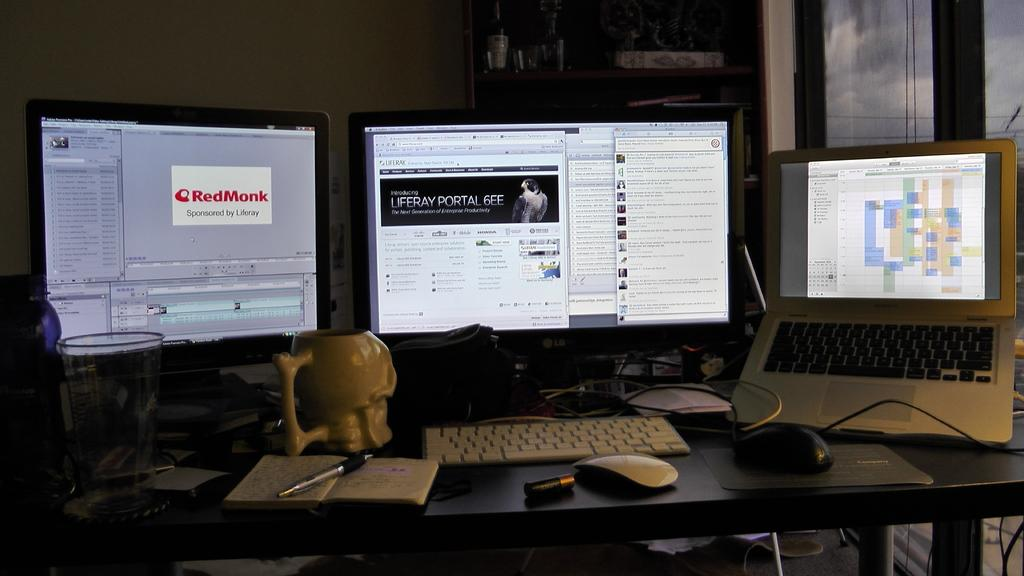What type of electronic device is visible in the image? There is a laptop in the image. What other technology-related items can be seen in the image? There are monitors and a keyboard visible in the image. What non-technology items are present in the image? There is a book, a pen, a glass, and other unspecified items on the table. What type of crime is being committed in the image? There is no crime being committed in the image; it features a laptop, monitors, a keyboard, a book, a pen, a glass, and other unspecified items on the table. Where is the vacation destination shown in the image? There is no vacation destination shown in the image; it features a laptop, monitors, a keyboard, a book, a pen, a glass, and other unspecified items on the table. 